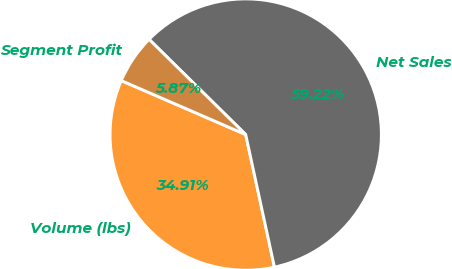Convert chart to OTSL. <chart><loc_0><loc_0><loc_500><loc_500><pie_chart><fcel>Volume (lbs)<fcel>Net Sales<fcel>Segment Profit<nl><fcel>34.91%<fcel>59.22%<fcel>5.87%<nl></chart> 